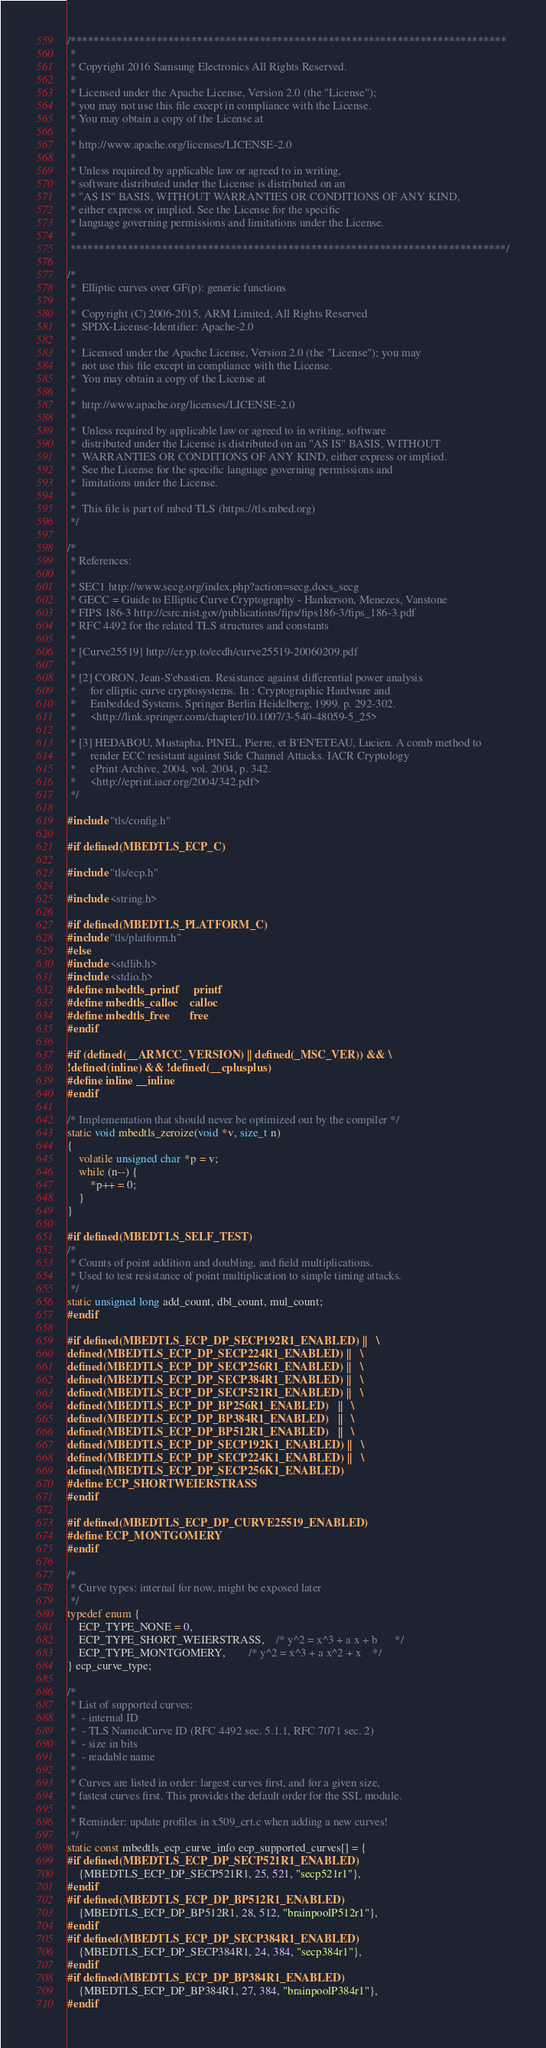<code> <loc_0><loc_0><loc_500><loc_500><_C_>/****************************************************************************
 *
 * Copyright 2016 Samsung Electronics All Rights Reserved.
 *
 * Licensed under the Apache License, Version 2.0 (the "License");
 * you may not use this file except in compliance with the License.
 * You may obtain a copy of the License at
 *
 * http://www.apache.org/licenses/LICENSE-2.0
 *
 * Unless required by applicable law or agreed to in writing,
 * software distributed under the License is distributed on an
 * "AS IS" BASIS, WITHOUT WARRANTIES OR CONDITIONS OF ANY KIND,
 * either express or implied. See the License for the specific
 * language governing permissions and limitations under the License.
 *
 ****************************************************************************/

/*
 *  Elliptic curves over GF(p): generic functions
 *
 *  Copyright (C) 2006-2015, ARM Limited, All Rights Reserved
 *  SPDX-License-Identifier: Apache-2.0
 *
 *  Licensed under the Apache License, Version 2.0 (the "License"); you may
 *  not use this file except in compliance with the License.
 *  You may obtain a copy of the License at
 *
 *  http://www.apache.org/licenses/LICENSE-2.0
 *
 *  Unless required by applicable law or agreed to in writing, software
 *  distributed under the License is distributed on an "AS IS" BASIS, WITHOUT
 *  WARRANTIES OR CONDITIONS OF ANY KIND, either express or implied.
 *  See the License for the specific language governing permissions and
 *  limitations under the License.
 *
 *  This file is part of mbed TLS (https://tls.mbed.org)
 */

/*
 * References:
 *
 * SEC1 http://www.secg.org/index.php?action=secg,docs_secg
 * GECC = Guide to Elliptic Curve Cryptography - Hankerson, Menezes, Vanstone
 * FIPS 186-3 http://csrc.nist.gov/publications/fips/fips186-3/fips_186-3.pdf
 * RFC 4492 for the related TLS structures and constants
 *
 * [Curve25519] http://cr.yp.to/ecdh/curve25519-20060209.pdf
 *
 * [2] CORON, Jean-S'ebastien. Resistance against differential power analysis
 *     for elliptic curve cryptosystems. In : Cryptographic Hardware and
 *     Embedded Systems. Springer Berlin Heidelberg, 1999. p. 292-302.
 *     <http://link.springer.com/chapter/10.1007/3-540-48059-5_25>
 *
 * [3] HEDABOU, Mustapha, PINEL, Pierre, et B'EN'ETEAU, Lucien. A comb method to
 *     render ECC resistant against Side Channel Attacks. IACR Cryptology
 *     ePrint Archive, 2004, vol. 2004, p. 342.
 *     <http://eprint.iacr.org/2004/342.pdf>
 */

#include "tls/config.h"

#if defined(MBEDTLS_ECP_C)

#include "tls/ecp.h"

#include <string.h>

#if defined(MBEDTLS_PLATFORM_C)
#include "tls/platform.h"
#else
#include <stdlib.h>
#include <stdio.h>
#define mbedtls_printf     printf
#define mbedtls_calloc    calloc
#define mbedtls_free       free
#endif

#if (defined(__ARMCC_VERSION) || defined(_MSC_VER)) && \
!defined(inline) && !defined(__cplusplus)
#define inline __inline
#endif

/* Implementation that should never be optimized out by the compiler */
static void mbedtls_zeroize(void *v, size_t n)
{
	volatile unsigned char *p = v;
	while (n--) {
		*p++ = 0;
	}
}

#if defined(MBEDTLS_SELF_TEST)
/*
 * Counts of point addition and doubling, and field multiplications.
 * Used to test resistance of point multiplication to simple timing attacks.
 */
static unsigned long add_count, dbl_count, mul_count;
#endif

#if defined(MBEDTLS_ECP_DP_SECP192R1_ENABLED) ||   \
defined(MBEDTLS_ECP_DP_SECP224R1_ENABLED) ||   \
defined(MBEDTLS_ECP_DP_SECP256R1_ENABLED) ||   \
defined(MBEDTLS_ECP_DP_SECP384R1_ENABLED) ||   \
defined(MBEDTLS_ECP_DP_SECP521R1_ENABLED) ||   \
defined(MBEDTLS_ECP_DP_BP256R1_ENABLED)   ||   \
defined(MBEDTLS_ECP_DP_BP384R1_ENABLED)   ||   \
defined(MBEDTLS_ECP_DP_BP512R1_ENABLED)   ||   \
defined(MBEDTLS_ECP_DP_SECP192K1_ENABLED) ||   \
defined(MBEDTLS_ECP_DP_SECP224K1_ENABLED) ||   \
defined(MBEDTLS_ECP_DP_SECP256K1_ENABLED)
#define ECP_SHORTWEIERSTRASS
#endif

#if defined(MBEDTLS_ECP_DP_CURVE25519_ENABLED)
#define ECP_MONTGOMERY
#endif

/*
 * Curve types: internal for now, might be exposed later
 */
typedef enum {
	ECP_TYPE_NONE = 0,
	ECP_TYPE_SHORT_WEIERSTRASS,	/* y^2 = x^3 + a x + b      */
	ECP_TYPE_MONTGOMERY,		/* y^2 = x^3 + a x^2 + x    */
} ecp_curve_type;

/*
 * List of supported curves:
 *  - internal ID
 *  - TLS NamedCurve ID (RFC 4492 sec. 5.1.1, RFC 7071 sec. 2)
 *  - size in bits
 *  - readable name
 *
 * Curves are listed in order: largest curves first, and for a given size,
 * fastest curves first. This provides the default order for the SSL module.
 *
 * Reminder: update profiles in x509_crt.c when adding a new curves!
 */
static const mbedtls_ecp_curve_info ecp_supported_curves[] = {
#if defined(MBEDTLS_ECP_DP_SECP521R1_ENABLED)
	{MBEDTLS_ECP_DP_SECP521R1, 25, 521, "secp521r1"},
#endif
#if defined(MBEDTLS_ECP_DP_BP512R1_ENABLED)
	{MBEDTLS_ECP_DP_BP512R1, 28, 512, "brainpoolP512r1"},
#endif
#if defined(MBEDTLS_ECP_DP_SECP384R1_ENABLED)
	{MBEDTLS_ECP_DP_SECP384R1, 24, 384, "secp384r1"},
#endif
#if defined(MBEDTLS_ECP_DP_BP384R1_ENABLED)
	{MBEDTLS_ECP_DP_BP384R1, 27, 384, "brainpoolP384r1"},
#endif</code> 